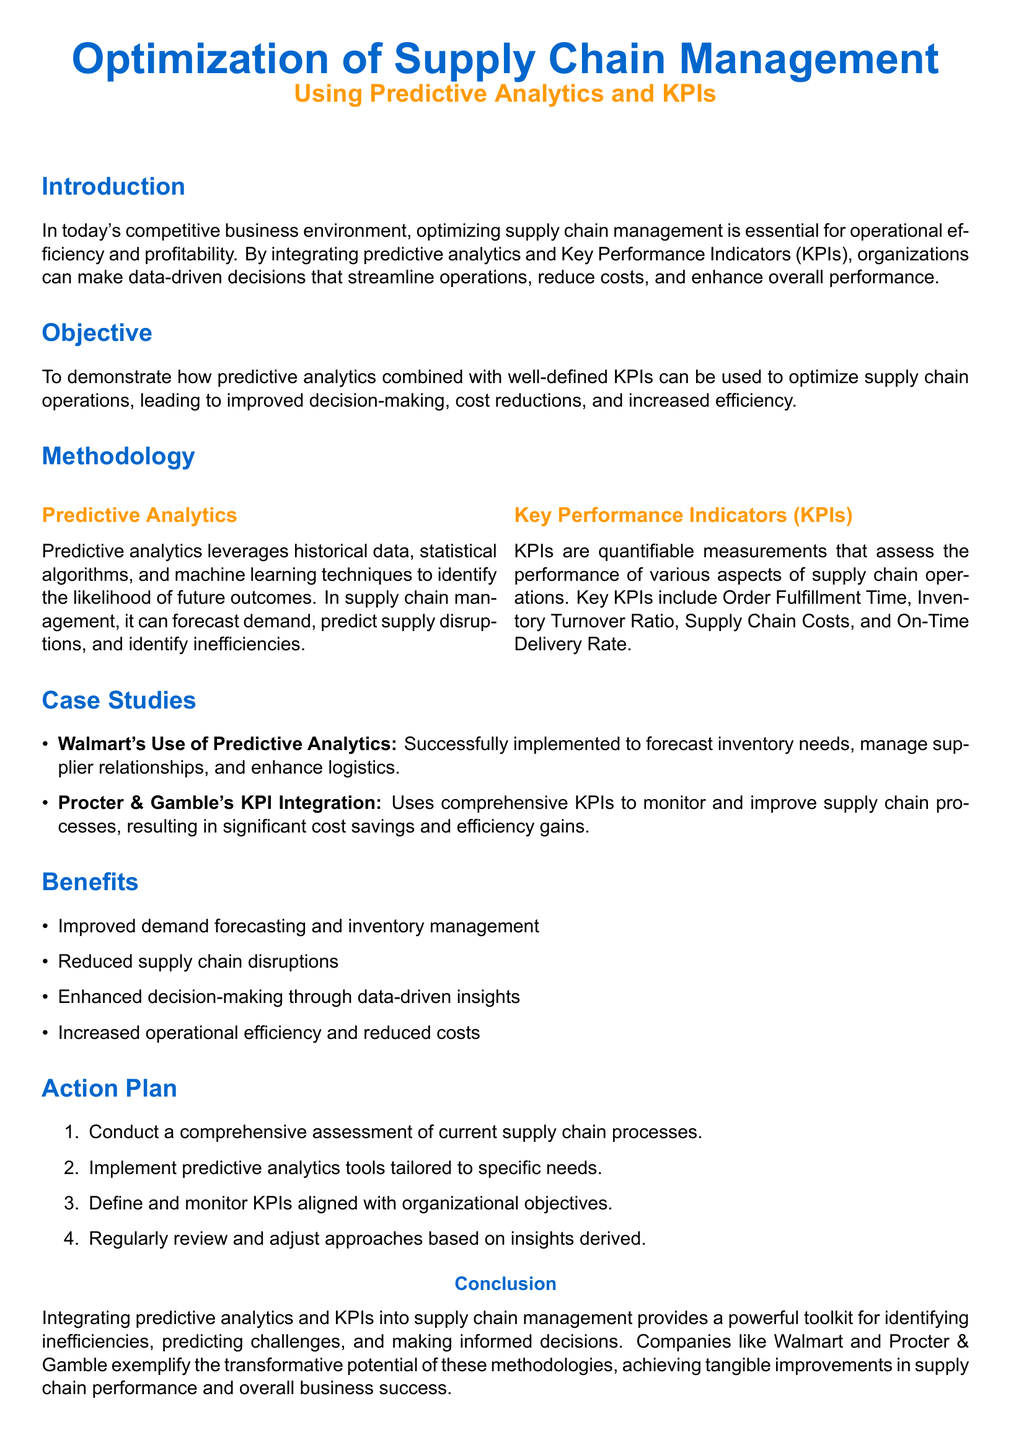What is the main focus of the proposal? The main focus is optimizing supply chain management using predictive analytics and KPIs.
Answer: Optimizing supply chain management What is a benefit of predictive analytics mentioned in the document? A benefit highlighted is improved demand forecasting and inventory management.
Answer: Improved demand forecasting What are the key KPIs listed in the proposal? The document lists Order Fulfillment Time, Inventory Turnover Ratio, Supply Chain Costs, and On-Time Delivery Rate as key KPIs.
Answer: Order Fulfillment Time, Inventory Turnover Ratio, Supply Chain Costs, On-Time Delivery Rate Which company successfully implemented predictive analytics? The proposal mentions Walmart as a company that successfully implemented predictive analytics.
Answer: Walmart What is the first step in the action plan? The first step outlined in the action plan is to conduct a comprehensive assessment of current supply chain processes.
Answer: Conduct a comprehensive assessment What was one significant outcome for Procter & Gamble? The document states that Procter & Gamble achieved significant cost savings and efficiency gains through KPI integration.
Answer: Significant cost savings What is the primary objective of the proposal? The primary objective is to demonstrate how predictive analytics combined with KPIs can optimize supply chain operations.
Answer: To demonstrate how predictive analytics combined with KPIs can optimize supply chain operations What methodology is discussed in the document for supply chain optimization? The methodology discussed includes predictive analytics and the use of KPIs.
Answer: Predictive analytics and KPIs What does the conclusion emphasize about predictive analytics and KPIs? The conclusion emphasizes that these methodologies help in identifying inefficiencies, predicting challenges, and making informed decisions.
Answer: Identifying inefficiencies and predicting challenges 